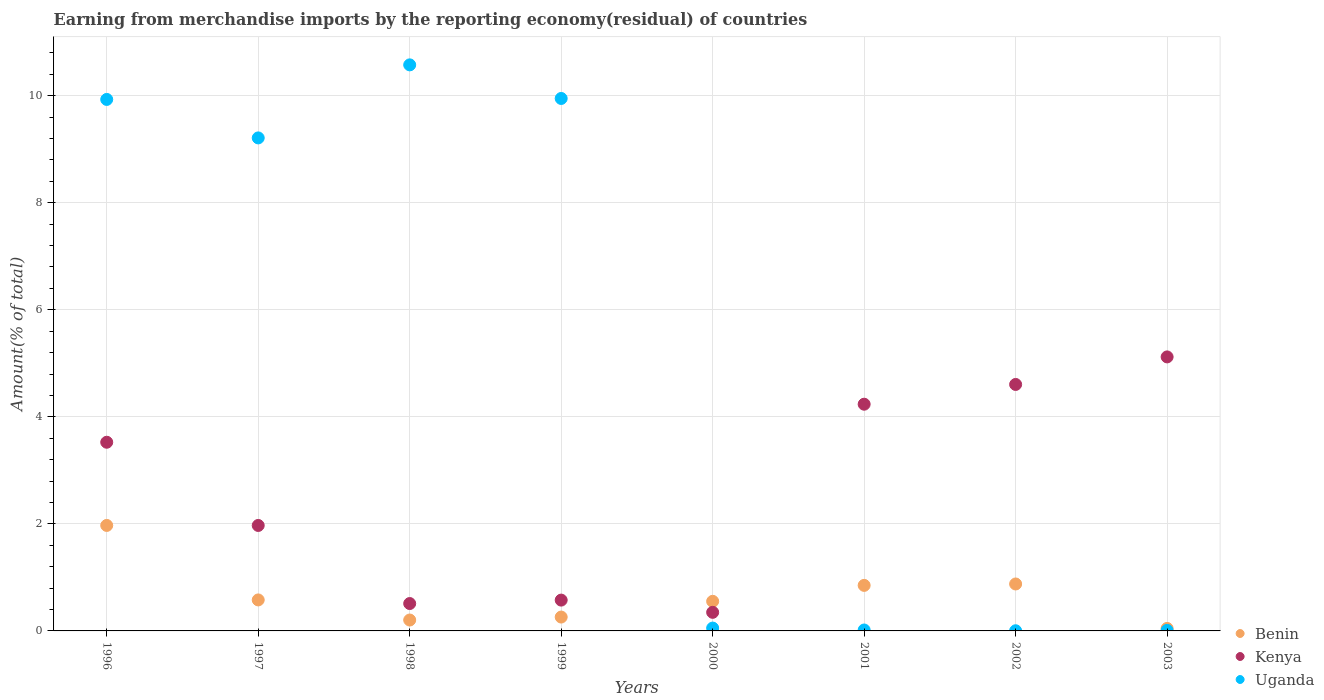How many different coloured dotlines are there?
Your answer should be compact. 3. Is the number of dotlines equal to the number of legend labels?
Ensure brevity in your answer.  Yes. What is the percentage of amount earned from merchandise imports in Benin in 2003?
Your response must be concise. 0.05. Across all years, what is the maximum percentage of amount earned from merchandise imports in Uganda?
Provide a short and direct response. 10.58. Across all years, what is the minimum percentage of amount earned from merchandise imports in Uganda?
Offer a very short reply. 0. In which year was the percentage of amount earned from merchandise imports in Benin maximum?
Offer a terse response. 1996. In which year was the percentage of amount earned from merchandise imports in Uganda minimum?
Keep it short and to the point. 2002. What is the total percentage of amount earned from merchandise imports in Kenya in the graph?
Offer a very short reply. 20.89. What is the difference between the percentage of amount earned from merchandise imports in Uganda in 1998 and that in 1999?
Offer a very short reply. 0.63. What is the difference between the percentage of amount earned from merchandise imports in Kenya in 2002 and the percentage of amount earned from merchandise imports in Uganda in 1997?
Offer a very short reply. -4.61. What is the average percentage of amount earned from merchandise imports in Benin per year?
Give a very brief answer. 0.67. In the year 2002, what is the difference between the percentage of amount earned from merchandise imports in Uganda and percentage of amount earned from merchandise imports in Kenya?
Offer a very short reply. -4.6. In how many years, is the percentage of amount earned from merchandise imports in Uganda greater than 6.8 %?
Your response must be concise. 4. What is the ratio of the percentage of amount earned from merchandise imports in Kenya in 1998 to that in 2000?
Make the answer very short. 1.47. Is the percentage of amount earned from merchandise imports in Kenya in 1996 less than that in 2002?
Your response must be concise. Yes. Is the difference between the percentage of amount earned from merchandise imports in Uganda in 1997 and 1999 greater than the difference between the percentage of amount earned from merchandise imports in Kenya in 1997 and 1999?
Give a very brief answer. No. What is the difference between the highest and the second highest percentage of amount earned from merchandise imports in Kenya?
Offer a terse response. 0.51. What is the difference between the highest and the lowest percentage of amount earned from merchandise imports in Uganda?
Offer a very short reply. 10.57. In how many years, is the percentage of amount earned from merchandise imports in Benin greater than the average percentage of amount earned from merchandise imports in Benin taken over all years?
Provide a short and direct response. 3. Is it the case that in every year, the sum of the percentage of amount earned from merchandise imports in Kenya and percentage of amount earned from merchandise imports in Benin  is greater than the percentage of amount earned from merchandise imports in Uganda?
Provide a short and direct response. No. Is the percentage of amount earned from merchandise imports in Uganda strictly greater than the percentage of amount earned from merchandise imports in Kenya over the years?
Ensure brevity in your answer.  No. Is the percentage of amount earned from merchandise imports in Kenya strictly less than the percentage of amount earned from merchandise imports in Benin over the years?
Keep it short and to the point. No. How many dotlines are there?
Your answer should be compact. 3. Does the graph contain any zero values?
Provide a succinct answer. No. How are the legend labels stacked?
Give a very brief answer. Vertical. What is the title of the graph?
Offer a terse response. Earning from merchandise imports by the reporting economy(residual) of countries. Does "Germany" appear as one of the legend labels in the graph?
Your response must be concise. No. What is the label or title of the X-axis?
Provide a succinct answer. Years. What is the label or title of the Y-axis?
Make the answer very short. Amount(% of total). What is the Amount(% of total) in Benin in 1996?
Make the answer very short. 1.97. What is the Amount(% of total) of Kenya in 1996?
Provide a succinct answer. 3.53. What is the Amount(% of total) in Uganda in 1996?
Give a very brief answer. 9.93. What is the Amount(% of total) of Benin in 1997?
Give a very brief answer. 0.58. What is the Amount(% of total) of Kenya in 1997?
Your response must be concise. 1.97. What is the Amount(% of total) of Uganda in 1997?
Your answer should be very brief. 9.21. What is the Amount(% of total) in Benin in 1998?
Make the answer very short. 0.2. What is the Amount(% of total) of Kenya in 1998?
Your response must be concise. 0.51. What is the Amount(% of total) of Uganda in 1998?
Your answer should be very brief. 10.58. What is the Amount(% of total) in Benin in 1999?
Provide a succinct answer. 0.26. What is the Amount(% of total) in Kenya in 1999?
Your answer should be very brief. 0.58. What is the Amount(% of total) of Uganda in 1999?
Offer a terse response. 9.95. What is the Amount(% of total) in Benin in 2000?
Your answer should be compact. 0.55. What is the Amount(% of total) in Kenya in 2000?
Offer a very short reply. 0.35. What is the Amount(% of total) in Uganda in 2000?
Ensure brevity in your answer.  0.05. What is the Amount(% of total) in Benin in 2001?
Your answer should be compact. 0.85. What is the Amount(% of total) in Kenya in 2001?
Keep it short and to the point. 4.24. What is the Amount(% of total) in Uganda in 2001?
Ensure brevity in your answer.  0.02. What is the Amount(% of total) of Benin in 2002?
Make the answer very short. 0.88. What is the Amount(% of total) of Kenya in 2002?
Your answer should be very brief. 4.61. What is the Amount(% of total) of Uganda in 2002?
Your response must be concise. 0. What is the Amount(% of total) in Benin in 2003?
Your response must be concise. 0.05. What is the Amount(% of total) of Kenya in 2003?
Give a very brief answer. 5.12. What is the Amount(% of total) in Uganda in 2003?
Provide a succinct answer. 0.01. Across all years, what is the maximum Amount(% of total) in Benin?
Provide a succinct answer. 1.97. Across all years, what is the maximum Amount(% of total) of Kenya?
Give a very brief answer. 5.12. Across all years, what is the maximum Amount(% of total) in Uganda?
Your answer should be very brief. 10.58. Across all years, what is the minimum Amount(% of total) in Benin?
Offer a terse response. 0.05. Across all years, what is the minimum Amount(% of total) of Kenya?
Provide a succinct answer. 0.35. Across all years, what is the minimum Amount(% of total) of Uganda?
Ensure brevity in your answer.  0. What is the total Amount(% of total) of Benin in the graph?
Provide a short and direct response. 5.34. What is the total Amount(% of total) of Kenya in the graph?
Offer a terse response. 20.89. What is the total Amount(% of total) in Uganda in the graph?
Offer a terse response. 39.75. What is the difference between the Amount(% of total) in Benin in 1996 and that in 1997?
Provide a short and direct response. 1.39. What is the difference between the Amount(% of total) of Kenya in 1996 and that in 1997?
Your answer should be very brief. 1.55. What is the difference between the Amount(% of total) of Uganda in 1996 and that in 1997?
Ensure brevity in your answer.  0.72. What is the difference between the Amount(% of total) in Benin in 1996 and that in 1998?
Make the answer very short. 1.77. What is the difference between the Amount(% of total) of Kenya in 1996 and that in 1998?
Your answer should be very brief. 3.01. What is the difference between the Amount(% of total) of Uganda in 1996 and that in 1998?
Offer a terse response. -0.65. What is the difference between the Amount(% of total) of Benin in 1996 and that in 1999?
Provide a succinct answer. 1.71. What is the difference between the Amount(% of total) of Kenya in 1996 and that in 1999?
Ensure brevity in your answer.  2.95. What is the difference between the Amount(% of total) in Uganda in 1996 and that in 1999?
Your answer should be very brief. -0.02. What is the difference between the Amount(% of total) of Benin in 1996 and that in 2000?
Offer a terse response. 1.42. What is the difference between the Amount(% of total) in Kenya in 1996 and that in 2000?
Offer a very short reply. 3.18. What is the difference between the Amount(% of total) of Uganda in 1996 and that in 2000?
Your answer should be very brief. 9.88. What is the difference between the Amount(% of total) in Benin in 1996 and that in 2001?
Provide a short and direct response. 1.12. What is the difference between the Amount(% of total) of Kenya in 1996 and that in 2001?
Give a very brief answer. -0.71. What is the difference between the Amount(% of total) of Uganda in 1996 and that in 2001?
Keep it short and to the point. 9.91. What is the difference between the Amount(% of total) in Benin in 1996 and that in 2002?
Provide a succinct answer. 1.09. What is the difference between the Amount(% of total) of Kenya in 1996 and that in 2002?
Keep it short and to the point. -1.08. What is the difference between the Amount(% of total) of Uganda in 1996 and that in 2002?
Offer a very short reply. 9.93. What is the difference between the Amount(% of total) of Benin in 1996 and that in 2003?
Offer a very short reply. 1.92. What is the difference between the Amount(% of total) in Kenya in 1996 and that in 2003?
Make the answer very short. -1.59. What is the difference between the Amount(% of total) in Uganda in 1996 and that in 2003?
Your answer should be compact. 9.92. What is the difference between the Amount(% of total) in Benin in 1997 and that in 1998?
Offer a very short reply. 0.38. What is the difference between the Amount(% of total) of Kenya in 1997 and that in 1998?
Offer a terse response. 1.46. What is the difference between the Amount(% of total) in Uganda in 1997 and that in 1998?
Give a very brief answer. -1.36. What is the difference between the Amount(% of total) in Benin in 1997 and that in 1999?
Offer a terse response. 0.32. What is the difference between the Amount(% of total) of Kenya in 1997 and that in 1999?
Keep it short and to the point. 1.39. What is the difference between the Amount(% of total) in Uganda in 1997 and that in 1999?
Ensure brevity in your answer.  -0.74. What is the difference between the Amount(% of total) of Benin in 1997 and that in 2000?
Your response must be concise. 0.03. What is the difference between the Amount(% of total) in Kenya in 1997 and that in 2000?
Your answer should be compact. 1.62. What is the difference between the Amount(% of total) in Uganda in 1997 and that in 2000?
Ensure brevity in your answer.  9.16. What is the difference between the Amount(% of total) of Benin in 1997 and that in 2001?
Your response must be concise. -0.27. What is the difference between the Amount(% of total) in Kenya in 1997 and that in 2001?
Offer a terse response. -2.27. What is the difference between the Amount(% of total) in Uganda in 1997 and that in 2001?
Your response must be concise. 9.19. What is the difference between the Amount(% of total) of Benin in 1997 and that in 2002?
Offer a terse response. -0.3. What is the difference between the Amount(% of total) of Kenya in 1997 and that in 2002?
Your answer should be compact. -2.63. What is the difference between the Amount(% of total) in Uganda in 1997 and that in 2002?
Give a very brief answer. 9.21. What is the difference between the Amount(% of total) of Benin in 1997 and that in 2003?
Offer a terse response. 0.53. What is the difference between the Amount(% of total) of Kenya in 1997 and that in 2003?
Your response must be concise. -3.15. What is the difference between the Amount(% of total) in Uganda in 1997 and that in 2003?
Your answer should be very brief. 9.2. What is the difference between the Amount(% of total) of Benin in 1998 and that in 1999?
Make the answer very short. -0.06. What is the difference between the Amount(% of total) in Kenya in 1998 and that in 1999?
Offer a terse response. -0.06. What is the difference between the Amount(% of total) in Uganda in 1998 and that in 1999?
Provide a short and direct response. 0.63. What is the difference between the Amount(% of total) in Benin in 1998 and that in 2000?
Provide a short and direct response. -0.35. What is the difference between the Amount(% of total) of Kenya in 1998 and that in 2000?
Provide a succinct answer. 0.16. What is the difference between the Amount(% of total) of Uganda in 1998 and that in 2000?
Your response must be concise. 10.52. What is the difference between the Amount(% of total) of Benin in 1998 and that in 2001?
Offer a terse response. -0.65. What is the difference between the Amount(% of total) of Kenya in 1998 and that in 2001?
Make the answer very short. -3.72. What is the difference between the Amount(% of total) of Uganda in 1998 and that in 2001?
Give a very brief answer. 10.56. What is the difference between the Amount(% of total) in Benin in 1998 and that in 2002?
Your answer should be compact. -0.67. What is the difference between the Amount(% of total) of Kenya in 1998 and that in 2002?
Keep it short and to the point. -4.09. What is the difference between the Amount(% of total) in Uganda in 1998 and that in 2002?
Give a very brief answer. 10.57. What is the difference between the Amount(% of total) in Benin in 1998 and that in 2003?
Make the answer very short. 0.16. What is the difference between the Amount(% of total) of Kenya in 1998 and that in 2003?
Give a very brief answer. -4.61. What is the difference between the Amount(% of total) in Uganda in 1998 and that in 2003?
Your response must be concise. 10.57. What is the difference between the Amount(% of total) of Benin in 1999 and that in 2000?
Ensure brevity in your answer.  -0.29. What is the difference between the Amount(% of total) in Kenya in 1999 and that in 2000?
Provide a succinct answer. 0.23. What is the difference between the Amount(% of total) of Uganda in 1999 and that in 2000?
Offer a very short reply. 9.9. What is the difference between the Amount(% of total) of Benin in 1999 and that in 2001?
Provide a succinct answer. -0.59. What is the difference between the Amount(% of total) of Kenya in 1999 and that in 2001?
Keep it short and to the point. -3.66. What is the difference between the Amount(% of total) in Uganda in 1999 and that in 2001?
Your answer should be very brief. 9.93. What is the difference between the Amount(% of total) of Benin in 1999 and that in 2002?
Make the answer very short. -0.62. What is the difference between the Amount(% of total) of Kenya in 1999 and that in 2002?
Ensure brevity in your answer.  -4.03. What is the difference between the Amount(% of total) of Uganda in 1999 and that in 2002?
Ensure brevity in your answer.  9.95. What is the difference between the Amount(% of total) in Benin in 1999 and that in 2003?
Keep it short and to the point. 0.21. What is the difference between the Amount(% of total) in Kenya in 1999 and that in 2003?
Provide a succinct answer. -4.54. What is the difference between the Amount(% of total) of Uganda in 1999 and that in 2003?
Your answer should be very brief. 9.94. What is the difference between the Amount(% of total) in Benin in 2000 and that in 2001?
Your answer should be very brief. -0.3. What is the difference between the Amount(% of total) in Kenya in 2000 and that in 2001?
Ensure brevity in your answer.  -3.89. What is the difference between the Amount(% of total) of Uganda in 2000 and that in 2001?
Give a very brief answer. 0.04. What is the difference between the Amount(% of total) of Benin in 2000 and that in 2002?
Your answer should be compact. -0.32. What is the difference between the Amount(% of total) of Kenya in 2000 and that in 2002?
Offer a very short reply. -4.26. What is the difference between the Amount(% of total) of Uganda in 2000 and that in 2002?
Your response must be concise. 0.05. What is the difference between the Amount(% of total) in Benin in 2000 and that in 2003?
Your answer should be compact. 0.51. What is the difference between the Amount(% of total) of Kenya in 2000 and that in 2003?
Your answer should be compact. -4.77. What is the difference between the Amount(% of total) of Uganda in 2000 and that in 2003?
Provide a succinct answer. 0.04. What is the difference between the Amount(% of total) of Benin in 2001 and that in 2002?
Offer a very short reply. -0.03. What is the difference between the Amount(% of total) in Kenya in 2001 and that in 2002?
Your answer should be very brief. -0.37. What is the difference between the Amount(% of total) of Uganda in 2001 and that in 2002?
Give a very brief answer. 0.01. What is the difference between the Amount(% of total) of Benin in 2001 and that in 2003?
Make the answer very short. 0.8. What is the difference between the Amount(% of total) of Kenya in 2001 and that in 2003?
Provide a short and direct response. -0.88. What is the difference between the Amount(% of total) in Uganda in 2001 and that in 2003?
Your answer should be compact. 0.01. What is the difference between the Amount(% of total) of Benin in 2002 and that in 2003?
Ensure brevity in your answer.  0.83. What is the difference between the Amount(% of total) of Kenya in 2002 and that in 2003?
Make the answer very short. -0.51. What is the difference between the Amount(% of total) of Uganda in 2002 and that in 2003?
Provide a succinct answer. -0.01. What is the difference between the Amount(% of total) in Benin in 1996 and the Amount(% of total) in Uganda in 1997?
Your response must be concise. -7.24. What is the difference between the Amount(% of total) of Kenya in 1996 and the Amount(% of total) of Uganda in 1997?
Give a very brief answer. -5.69. What is the difference between the Amount(% of total) of Benin in 1996 and the Amount(% of total) of Kenya in 1998?
Provide a short and direct response. 1.46. What is the difference between the Amount(% of total) of Benin in 1996 and the Amount(% of total) of Uganda in 1998?
Ensure brevity in your answer.  -8.61. What is the difference between the Amount(% of total) in Kenya in 1996 and the Amount(% of total) in Uganda in 1998?
Your answer should be compact. -7.05. What is the difference between the Amount(% of total) in Benin in 1996 and the Amount(% of total) in Kenya in 1999?
Provide a succinct answer. 1.4. What is the difference between the Amount(% of total) in Benin in 1996 and the Amount(% of total) in Uganda in 1999?
Your answer should be compact. -7.98. What is the difference between the Amount(% of total) of Kenya in 1996 and the Amount(% of total) of Uganda in 1999?
Keep it short and to the point. -6.42. What is the difference between the Amount(% of total) of Benin in 1996 and the Amount(% of total) of Kenya in 2000?
Provide a succinct answer. 1.62. What is the difference between the Amount(% of total) in Benin in 1996 and the Amount(% of total) in Uganda in 2000?
Provide a succinct answer. 1.92. What is the difference between the Amount(% of total) of Kenya in 1996 and the Amount(% of total) of Uganda in 2000?
Give a very brief answer. 3.47. What is the difference between the Amount(% of total) in Benin in 1996 and the Amount(% of total) in Kenya in 2001?
Provide a short and direct response. -2.27. What is the difference between the Amount(% of total) in Benin in 1996 and the Amount(% of total) in Uganda in 2001?
Your response must be concise. 1.95. What is the difference between the Amount(% of total) of Kenya in 1996 and the Amount(% of total) of Uganda in 2001?
Offer a terse response. 3.51. What is the difference between the Amount(% of total) of Benin in 1996 and the Amount(% of total) of Kenya in 2002?
Your answer should be very brief. -2.63. What is the difference between the Amount(% of total) in Benin in 1996 and the Amount(% of total) in Uganda in 2002?
Your answer should be very brief. 1.97. What is the difference between the Amount(% of total) of Kenya in 1996 and the Amount(% of total) of Uganda in 2002?
Provide a succinct answer. 3.52. What is the difference between the Amount(% of total) in Benin in 1996 and the Amount(% of total) in Kenya in 2003?
Keep it short and to the point. -3.15. What is the difference between the Amount(% of total) of Benin in 1996 and the Amount(% of total) of Uganda in 2003?
Give a very brief answer. 1.96. What is the difference between the Amount(% of total) of Kenya in 1996 and the Amount(% of total) of Uganda in 2003?
Offer a terse response. 3.52. What is the difference between the Amount(% of total) in Benin in 1997 and the Amount(% of total) in Kenya in 1998?
Your answer should be very brief. 0.07. What is the difference between the Amount(% of total) of Benin in 1997 and the Amount(% of total) of Uganda in 1998?
Give a very brief answer. -10. What is the difference between the Amount(% of total) in Kenya in 1997 and the Amount(% of total) in Uganda in 1998?
Ensure brevity in your answer.  -8.61. What is the difference between the Amount(% of total) of Benin in 1997 and the Amount(% of total) of Kenya in 1999?
Offer a terse response. 0. What is the difference between the Amount(% of total) in Benin in 1997 and the Amount(% of total) in Uganda in 1999?
Your answer should be very brief. -9.37. What is the difference between the Amount(% of total) in Kenya in 1997 and the Amount(% of total) in Uganda in 1999?
Give a very brief answer. -7.98. What is the difference between the Amount(% of total) in Benin in 1997 and the Amount(% of total) in Kenya in 2000?
Keep it short and to the point. 0.23. What is the difference between the Amount(% of total) of Benin in 1997 and the Amount(% of total) of Uganda in 2000?
Your response must be concise. 0.53. What is the difference between the Amount(% of total) of Kenya in 1997 and the Amount(% of total) of Uganda in 2000?
Your response must be concise. 1.92. What is the difference between the Amount(% of total) of Benin in 1997 and the Amount(% of total) of Kenya in 2001?
Your answer should be very brief. -3.66. What is the difference between the Amount(% of total) of Benin in 1997 and the Amount(% of total) of Uganda in 2001?
Your answer should be very brief. 0.56. What is the difference between the Amount(% of total) of Kenya in 1997 and the Amount(% of total) of Uganda in 2001?
Your response must be concise. 1.95. What is the difference between the Amount(% of total) of Benin in 1997 and the Amount(% of total) of Kenya in 2002?
Your answer should be very brief. -4.03. What is the difference between the Amount(% of total) in Benin in 1997 and the Amount(% of total) in Uganda in 2002?
Your response must be concise. 0.58. What is the difference between the Amount(% of total) of Kenya in 1997 and the Amount(% of total) of Uganda in 2002?
Keep it short and to the point. 1.97. What is the difference between the Amount(% of total) in Benin in 1997 and the Amount(% of total) in Kenya in 2003?
Your answer should be compact. -4.54. What is the difference between the Amount(% of total) of Benin in 1997 and the Amount(% of total) of Uganda in 2003?
Your answer should be very brief. 0.57. What is the difference between the Amount(% of total) of Kenya in 1997 and the Amount(% of total) of Uganda in 2003?
Your answer should be very brief. 1.96. What is the difference between the Amount(% of total) of Benin in 1998 and the Amount(% of total) of Kenya in 1999?
Your answer should be compact. -0.37. What is the difference between the Amount(% of total) in Benin in 1998 and the Amount(% of total) in Uganda in 1999?
Offer a terse response. -9.74. What is the difference between the Amount(% of total) in Kenya in 1998 and the Amount(% of total) in Uganda in 1999?
Make the answer very short. -9.44. What is the difference between the Amount(% of total) in Benin in 1998 and the Amount(% of total) in Kenya in 2000?
Make the answer very short. -0.14. What is the difference between the Amount(% of total) of Benin in 1998 and the Amount(% of total) of Uganda in 2000?
Provide a succinct answer. 0.15. What is the difference between the Amount(% of total) in Kenya in 1998 and the Amount(% of total) in Uganda in 2000?
Your answer should be compact. 0.46. What is the difference between the Amount(% of total) of Benin in 1998 and the Amount(% of total) of Kenya in 2001?
Keep it short and to the point. -4.03. What is the difference between the Amount(% of total) of Benin in 1998 and the Amount(% of total) of Uganda in 2001?
Provide a succinct answer. 0.19. What is the difference between the Amount(% of total) of Kenya in 1998 and the Amount(% of total) of Uganda in 2001?
Provide a succinct answer. 0.49. What is the difference between the Amount(% of total) in Benin in 1998 and the Amount(% of total) in Kenya in 2002?
Your answer should be compact. -4.4. What is the difference between the Amount(% of total) of Benin in 1998 and the Amount(% of total) of Uganda in 2002?
Ensure brevity in your answer.  0.2. What is the difference between the Amount(% of total) in Kenya in 1998 and the Amount(% of total) in Uganda in 2002?
Your answer should be very brief. 0.51. What is the difference between the Amount(% of total) of Benin in 1998 and the Amount(% of total) of Kenya in 2003?
Keep it short and to the point. -4.92. What is the difference between the Amount(% of total) of Benin in 1998 and the Amount(% of total) of Uganda in 2003?
Offer a very short reply. 0.19. What is the difference between the Amount(% of total) of Kenya in 1998 and the Amount(% of total) of Uganda in 2003?
Your response must be concise. 0.5. What is the difference between the Amount(% of total) in Benin in 1999 and the Amount(% of total) in Kenya in 2000?
Make the answer very short. -0.09. What is the difference between the Amount(% of total) of Benin in 1999 and the Amount(% of total) of Uganda in 2000?
Provide a succinct answer. 0.21. What is the difference between the Amount(% of total) in Kenya in 1999 and the Amount(% of total) in Uganda in 2000?
Make the answer very short. 0.52. What is the difference between the Amount(% of total) of Benin in 1999 and the Amount(% of total) of Kenya in 2001?
Provide a succinct answer. -3.98. What is the difference between the Amount(% of total) of Benin in 1999 and the Amount(% of total) of Uganda in 2001?
Your response must be concise. 0.24. What is the difference between the Amount(% of total) in Kenya in 1999 and the Amount(% of total) in Uganda in 2001?
Give a very brief answer. 0.56. What is the difference between the Amount(% of total) of Benin in 1999 and the Amount(% of total) of Kenya in 2002?
Provide a short and direct response. -4.35. What is the difference between the Amount(% of total) of Benin in 1999 and the Amount(% of total) of Uganda in 2002?
Provide a short and direct response. 0.26. What is the difference between the Amount(% of total) in Kenya in 1999 and the Amount(% of total) in Uganda in 2002?
Offer a terse response. 0.57. What is the difference between the Amount(% of total) in Benin in 1999 and the Amount(% of total) in Kenya in 2003?
Your answer should be compact. -4.86. What is the difference between the Amount(% of total) in Benin in 1999 and the Amount(% of total) in Uganda in 2003?
Keep it short and to the point. 0.25. What is the difference between the Amount(% of total) in Kenya in 1999 and the Amount(% of total) in Uganda in 2003?
Ensure brevity in your answer.  0.57. What is the difference between the Amount(% of total) of Benin in 2000 and the Amount(% of total) of Kenya in 2001?
Your answer should be very brief. -3.68. What is the difference between the Amount(% of total) of Benin in 2000 and the Amount(% of total) of Uganda in 2001?
Ensure brevity in your answer.  0.54. What is the difference between the Amount(% of total) in Kenya in 2000 and the Amount(% of total) in Uganda in 2001?
Offer a terse response. 0.33. What is the difference between the Amount(% of total) of Benin in 2000 and the Amount(% of total) of Kenya in 2002?
Your answer should be compact. -4.05. What is the difference between the Amount(% of total) in Benin in 2000 and the Amount(% of total) in Uganda in 2002?
Offer a terse response. 0.55. What is the difference between the Amount(% of total) of Kenya in 2000 and the Amount(% of total) of Uganda in 2002?
Your answer should be compact. 0.34. What is the difference between the Amount(% of total) of Benin in 2000 and the Amount(% of total) of Kenya in 2003?
Keep it short and to the point. -4.57. What is the difference between the Amount(% of total) in Benin in 2000 and the Amount(% of total) in Uganda in 2003?
Keep it short and to the point. 0.54. What is the difference between the Amount(% of total) of Kenya in 2000 and the Amount(% of total) of Uganda in 2003?
Your answer should be very brief. 0.34. What is the difference between the Amount(% of total) of Benin in 2001 and the Amount(% of total) of Kenya in 2002?
Offer a terse response. -3.75. What is the difference between the Amount(% of total) of Benin in 2001 and the Amount(% of total) of Uganda in 2002?
Offer a very short reply. 0.85. What is the difference between the Amount(% of total) of Kenya in 2001 and the Amount(% of total) of Uganda in 2002?
Offer a terse response. 4.23. What is the difference between the Amount(% of total) in Benin in 2001 and the Amount(% of total) in Kenya in 2003?
Provide a short and direct response. -4.27. What is the difference between the Amount(% of total) in Benin in 2001 and the Amount(% of total) in Uganda in 2003?
Your response must be concise. 0.84. What is the difference between the Amount(% of total) of Kenya in 2001 and the Amount(% of total) of Uganda in 2003?
Provide a succinct answer. 4.23. What is the difference between the Amount(% of total) in Benin in 2002 and the Amount(% of total) in Kenya in 2003?
Provide a succinct answer. -4.24. What is the difference between the Amount(% of total) of Benin in 2002 and the Amount(% of total) of Uganda in 2003?
Your response must be concise. 0.87. What is the difference between the Amount(% of total) of Kenya in 2002 and the Amount(% of total) of Uganda in 2003?
Your answer should be very brief. 4.6. What is the average Amount(% of total) of Benin per year?
Your response must be concise. 0.67. What is the average Amount(% of total) of Kenya per year?
Your answer should be compact. 2.61. What is the average Amount(% of total) in Uganda per year?
Provide a succinct answer. 4.97. In the year 1996, what is the difference between the Amount(% of total) of Benin and Amount(% of total) of Kenya?
Keep it short and to the point. -1.55. In the year 1996, what is the difference between the Amount(% of total) in Benin and Amount(% of total) in Uganda?
Give a very brief answer. -7.96. In the year 1996, what is the difference between the Amount(% of total) of Kenya and Amount(% of total) of Uganda?
Give a very brief answer. -6.41. In the year 1997, what is the difference between the Amount(% of total) of Benin and Amount(% of total) of Kenya?
Ensure brevity in your answer.  -1.39. In the year 1997, what is the difference between the Amount(% of total) of Benin and Amount(% of total) of Uganda?
Provide a succinct answer. -8.63. In the year 1997, what is the difference between the Amount(% of total) of Kenya and Amount(% of total) of Uganda?
Give a very brief answer. -7.24. In the year 1998, what is the difference between the Amount(% of total) of Benin and Amount(% of total) of Kenya?
Your answer should be compact. -0.31. In the year 1998, what is the difference between the Amount(% of total) of Benin and Amount(% of total) of Uganda?
Provide a short and direct response. -10.37. In the year 1998, what is the difference between the Amount(% of total) in Kenya and Amount(% of total) in Uganda?
Make the answer very short. -10.06. In the year 1999, what is the difference between the Amount(% of total) in Benin and Amount(% of total) in Kenya?
Provide a succinct answer. -0.32. In the year 1999, what is the difference between the Amount(% of total) of Benin and Amount(% of total) of Uganda?
Keep it short and to the point. -9.69. In the year 1999, what is the difference between the Amount(% of total) of Kenya and Amount(% of total) of Uganda?
Provide a succinct answer. -9.37. In the year 2000, what is the difference between the Amount(% of total) in Benin and Amount(% of total) in Kenya?
Your answer should be compact. 0.21. In the year 2000, what is the difference between the Amount(% of total) of Benin and Amount(% of total) of Uganda?
Provide a succinct answer. 0.5. In the year 2000, what is the difference between the Amount(% of total) in Kenya and Amount(% of total) in Uganda?
Give a very brief answer. 0.29. In the year 2001, what is the difference between the Amount(% of total) of Benin and Amount(% of total) of Kenya?
Your answer should be compact. -3.39. In the year 2001, what is the difference between the Amount(% of total) of Benin and Amount(% of total) of Uganda?
Your response must be concise. 0.83. In the year 2001, what is the difference between the Amount(% of total) of Kenya and Amount(% of total) of Uganda?
Provide a short and direct response. 4.22. In the year 2002, what is the difference between the Amount(% of total) of Benin and Amount(% of total) of Kenya?
Provide a short and direct response. -3.73. In the year 2002, what is the difference between the Amount(% of total) in Benin and Amount(% of total) in Uganda?
Your answer should be compact. 0.87. In the year 2002, what is the difference between the Amount(% of total) of Kenya and Amount(% of total) of Uganda?
Your answer should be compact. 4.6. In the year 2003, what is the difference between the Amount(% of total) in Benin and Amount(% of total) in Kenya?
Make the answer very short. -5.07. In the year 2003, what is the difference between the Amount(% of total) in Benin and Amount(% of total) in Uganda?
Provide a short and direct response. 0.04. In the year 2003, what is the difference between the Amount(% of total) in Kenya and Amount(% of total) in Uganda?
Offer a terse response. 5.11. What is the ratio of the Amount(% of total) of Benin in 1996 to that in 1997?
Provide a succinct answer. 3.4. What is the ratio of the Amount(% of total) of Kenya in 1996 to that in 1997?
Your response must be concise. 1.79. What is the ratio of the Amount(% of total) in Uganda in 1996 to that in 1997?
Make the answer very short. 1.08. What is the ratio of the Amount(% of total) in Benin in 1996 to that in 1998?
Your response must be concise. 9.68. What is the ratio of the Amount(% of total) of Kenya in 1996 to that in 1998?
Offer a terse response. 6.89. What is the ratio of the Amount(% of total) in Uganda in 1996 to that in 1998?
Your response must be concise. 0.94. What is the ratio of the Amount(% of total) of Benin in 1996 to that in 1999?
Make the answer very short. 7.61. What is the ratio of the Amount(% of total) of Kenya in 1996 to that in 1999?
Make the answer very short. 6.12. What is the ratio of the Amount(% of total) of Uganda in 1996 to that in 1999?
Give a very brief answer. 1. What is the ratio of the Amount(% of total) in Benin in 1996 to that in 2000?
Ensure brevity in your answer.  3.56. What is the ratio of the Amount(% of total) of Kenya in 1996 to that in 2000?
Your response must be concise. 10.15. What is the ratio of the Amount(% of total) in Uganda in 1996 to that in 2000?
Make the answer very short. 186.51. What is the ratio of the Amount(% of total) of Benin in 1996 to that in 2001?
Make the answer very short. 2.32. What is the ratio of the Amount(% of total) of Kenya in 1996 to that in 2001?
Keep it short and to the point. 0.83. What is the ratio of the Amount(% of total) of Uganda in 1996 to that in 2001?
Provide a short and direct response. 571.16. What is the ratio of the Amount(% of total) in Benin in 1996 to that in 2002?
Your response must be concise. 2.25. What is the ratio of the Amount(% of total) of Kenya in 1996 to that in 2002?
Your response must be concise. 0.77. What is the ratio of the Amount(% of total) in Uganda in 1996 to that in 2002?
Keep it short and to the point. 3161.66. What is the ratio of the Amount(% of total) of Benin in 1996 to that in 2003?
Ensure brevity in your answer.  42.53. What is the ratio of the Amount(% of total) in Kenya in 1996 to that in 2003?
Your answer should be compact. 0.69. What is the ratio of the Amount(% of total) of Uganda in 1996 to that in 2003?
Provide a succinct answer. 999.78. What is the ratio of the Amount(% of total) of Benin in 1997 to that in 1998?
Provide a short and direct response. 2.84. What is the ratio of the Amount(% of total) in Kenya in 1997 to that in 1998?
Your response must be concise. 3.85. What is the ratio of the Amount(% of total) in Uganda in 1997 to that in 1998?
Offer a very short reply. 0.87. What is the ratio of the Amount(% of total) in Benin in 1997 to that in 1999?
Your answer should be very brief. 2.24. What is the ratio of the Amount(% of total) of Kenya in 1997 to that in 1999?
Your response must be concise. 3.42. What is the ratio of the Amount(% of total) of Uganda in 1997 to that in 1999?
Make the answer very short. 0.93. What is the ratio of the Amount(% of total) in Benin in 1997 to that in 2000?
Your answer should be very brief. 1.05. What is the ratio of the Amount(% of total) of Kenya in 1997 to that in 2000?
Ensure brevity in your answer.  5.67. What is the ratio of the Amount(% of total) of Uganda in 1997 to that in 2000?
Offer a very short reply. 173.01. What is the ratio of the Amount(% of total) of Benin in 1997 to that in 2001?
Give a very brief answer. 0.68. What is the ratio of the Amount(% of total) in Kenya in 1997 to that in 2001?
Offer a terse response. 0.47. What is the ratio of the Amount(% of total) of Uganda in 1997 to that in 2001?
Offer a very short reply. 529.81. What is the ratio of the Amount(% of total) of Benin in 1997 to that in 2002?
Offer a very short reply. 0.66. What is the ratio of the Amount(% of total) in Kenya in 1997 to that in 2002?
Make the answer very short. 0.43. What is the ratio of the Amount(% of total) of Uganda in 1997 to that in 2002?
Give a very brief answer. 2932.77. What is the ratio of the Amount(% of total) of Benin in 1997 to that in 2003?
Your response must be concise. 12.5. What is the ratio of the Amount(% of total) of Kenya in 1997 to that in 2003?
Provide a short and direct response. 0.38. What is the ratio of the Amount(% of total) in Uganda in 1997 to that in 2003?
Provide a succinct answer. 927.4. What is the ratio of the Amount(% of total) in Benin in 1998 to that in 1999?
Your answer should be very brief. 0.79. What is the ratio of the Amount(% of total) in Kenya in 1998 to that in 1999?
Make the answer very short. 0.89. What is the ratio of the Amount(% of total) in Uganda in 1998 to that in 1999?
Give a very brief answer. 1.06. What is the ratio of the Amount(% of total) in Benin in 1998 to that in 2000?
Offer a terse response. 0.37. What is the ratio of the Amount(% of total) of Kenya in 1998 to that in 2000?
Keep it short and to the point. 1.47. What is the ratio of the Amount(% of total) in Uganda in 1998 to that in 2000?
Make the answer very short. 198.64. What is the ratio of the Amount(% of total) of Benin in 1998 to that in 2001?
Provide a succinct answer. 0.24. What is the ratio of the Amount(% of total) of Kenya in 1998 to that in 2001?
Your answer should be very brief. 0.12. What is the ratio of the Amount(% of total) of Uganda in 1998 to that in 2001?
Make the answer very short. 608.3. What is the ratio of the Amount(% of total) in Benin in 1998 to that in 2002?
Ensure brevity in your answer.  0.23. What is the ratio of the Amount(% of total) in Kenya in 1998 to that in 2002?
Offer a very short reply. 0.11. What is the ratio of the Amount(% of total) of Uganda in 1998 to that in 2002?
Offer a terse response. 3367.27. What is the ratio of the Amount(% of total) in Benin in 1998 to that in 2003?
Your answer should be very brief. 4.39. What is the ratio of the Amount(% of total) in Kenya in 1998 to that in 2003?
Provide a short and direct response. 0.1. What is the ratio of the Amount(% of total) in Uganda in 1998 to that in 2003?
Your answer should be very brief. 1064.79. What is the ratio of the Amount(% of total) of Benin in 1999 to that in 2000?
Provide a succinct answer. 0.47. What is the ratio of the Amount(% of total) of Kenya in 1999 to that in 2000?
Offer a very short reply. 1.66. What is the ratio of the Amount(% of total) of Uganda in 1999 to that in 2000?
Provide a succinct answer. 186.85. What is the ratio of the Amount(% of total) in Benin in 1999 to that in 2001?
Provide a short and direct response. 0.3. What is the ratio of the Amount(% of total) of Kenya in 1999 to that in 2001?
Your answer should be very brief. 0.14. What is the ratio of the Amount(% of total) of Uganda in 1999 to that in 2001?
Provide a short and direct response. 572.2. What is the ratio of the Amount(% of total) in Benin in 1999 to that in 2002?
Offer a terse response. 0.3. What is the ratio of the Amount(% of total) in Uganda in 1999 to that in 2002?
Your answer should be compact. 3167.4. What is the ratio of the Amount(% of total) in Benin in 1999 to that in 2003?
Give a very brief answer. 5.59. What is the ratio of the Amount(% of total) in Kenya in 1999 to that in 2003?
Your answer should be compact. 0.11. What is the ratio of the Amount(% of total) in Uganda in 1999 to that in 2003?
Ensure brevity in your answer.  1001.59. What is the ratio of the Amount(% of total) in Benin in 2000 to that in 2001?
Make the answer very short. 0.65. What is the ratio of the Amount(% of total) of Kenya in 2000 to that in 2001?
Give a very brief answer. 0.08. What is the ratio of the Amount(% of total) in Uganda in 2000 to that in 2001?
Ensure brevity in your answer.  3.06. What is the ratio of the Amount(% of total) of Benin in 2000 to that in 2002?
Your answer should be compact. 0.63. What is the ratio of the Amount(% of total) in Kenya in 2000 to that in 2002?
Ensure brevity in your answer.  0.08. What is the ratio of the Amount(% of total) of Uganda in 2000 to that in 2002?
Make the answer very short. 16.95. What is the ratio of the Amount(% of total) in Benin in 2000 to that in 2003?
Provide a short and direct response. 11.93. What is the ratio of the Amount(% of total) in Kenya in 2000 to that in 2003?
Offer a very short reply. 0.07. What is the ratio of the Amount(% of total) of Uganda in 2000 to that in 2003?
Keep it short and to the point. 5.36. What is the ratio of the Amount(% of total) of Benin in 2001 to that in 2002?
Your answer should be very brief. 0.97. What is the ratio of the Amount(% of total) in Kenya in 2001 to that in 2002?
Provide a succinct answer. 0.92. What is the ratio of the Amount(% of total) in Uganda in 2001 to that in 2002?
Make the answer very short. 5.54. What is the ratio of the Amount(% of total) of Benin in 2001 to that in 2003?
Your answer should be compact. 18.36. What is the ratio of the Amount(% of total) of Kenya in 2001 to that in 2003?
Provide a succinct answer. 0.83. What is the ratio of the Amount(% of total) in Uganda in 2001 to that in 2003?
Your response must be concise. 1.75. What is the ratio of the Amount(% of total) in Benin in 2002 to that in 2003?
Ensure brevity in your answer.  18.92. What is the ratio of the Amount(% of total) in Kenya in 2002 to that in 2003?
Your answer should be very brief. 0.9. What is the ratio of the Amount(% of total) of Uganda in 2002 to that in 2003?
Your answer should be very brief. 0.32. What is the difference between the highest and the second highest Amount(% of total) in Benin?
Provide a short and direct response. 1.09. What is the difference between the highest and the second highest Amount(% of total) of Kenya?
Your answer should be compact. 0.51. What is the difference between the highest and the second highest Amount(% of total) of Uganda?
Your response must be concise. 0.63. What is the difference between the highest and the lowest Amount(% of total) of Benin?
Ensure brevity in your answer.  1.92. What is the difference between the highest and the lowest Amount(% of total) of Kenya?
Your answer should be compact. 4.77. What is the difference between the highest and the lowest Amount(% of total) in Uganda?
Your answer should be very brief. 10.57. 